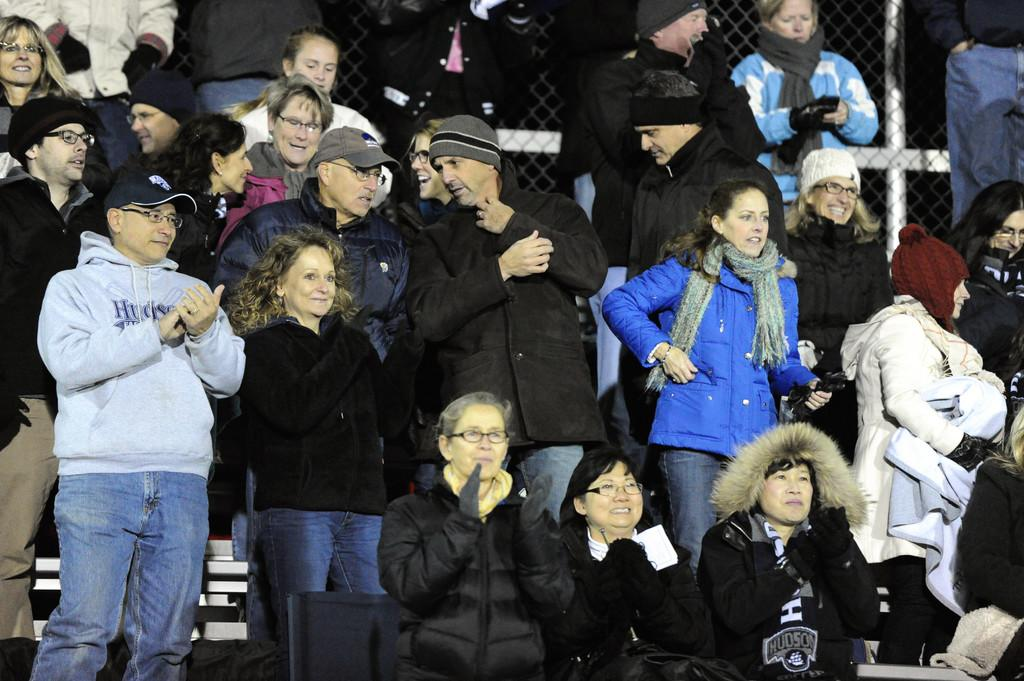How many people are in the image? There is a group of people standing in the image. What can be seen at the bottom of the image? There is an object at the bottom of the image. What is visible in the background of the image? There is a fence in the background of the image. What type of bird is perched on the fence in the image? There is no bird present in the image; only a group of people and a fence are visible. 